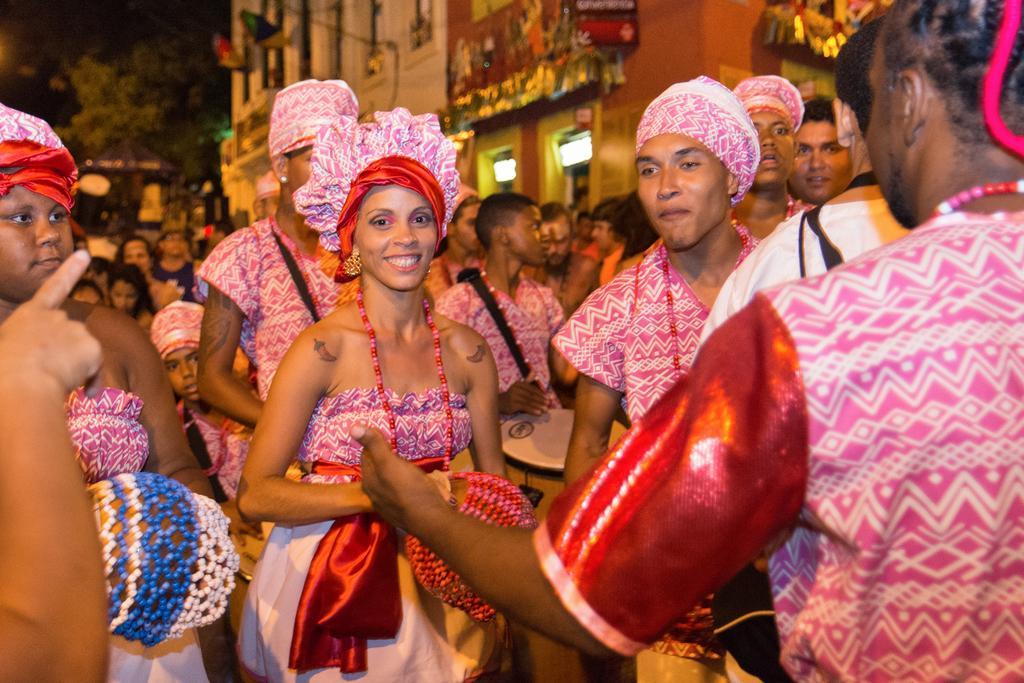Can you describe this image briefly? In this picture I can see there are few people standing here and they are wearing dresses and in the backdrop there is a building and there are trees at left side. 